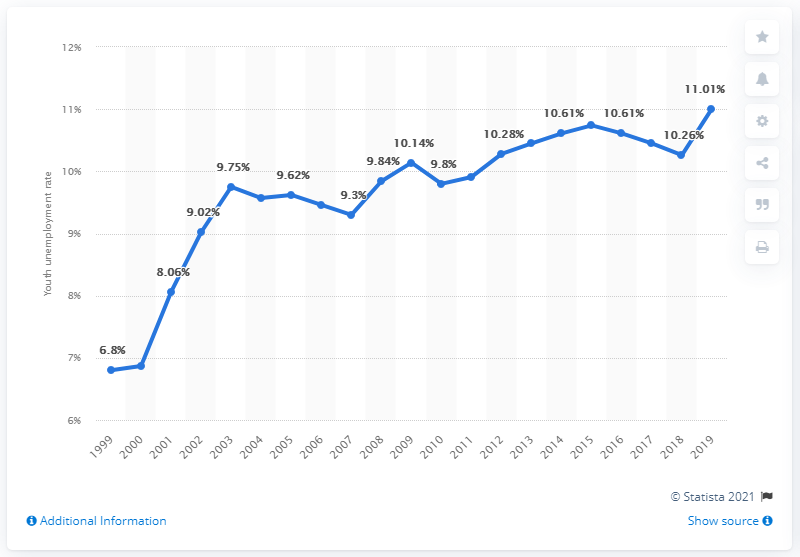Give some essential details in this illustration. In 2019, the youth unemployment rate in China was 11.01%. 